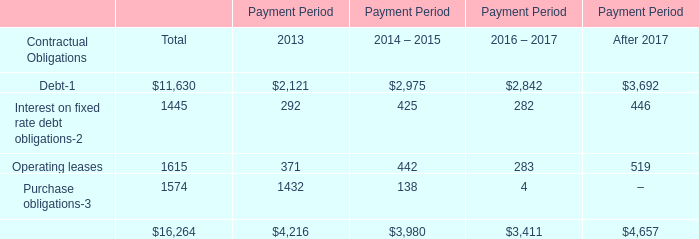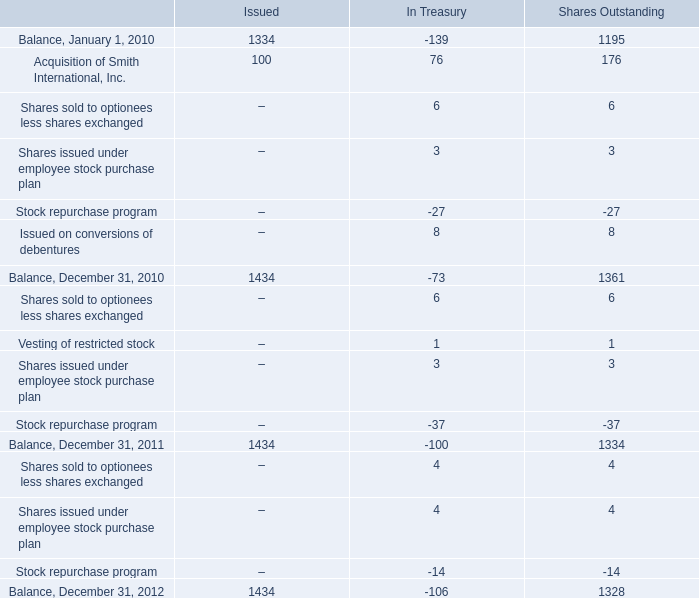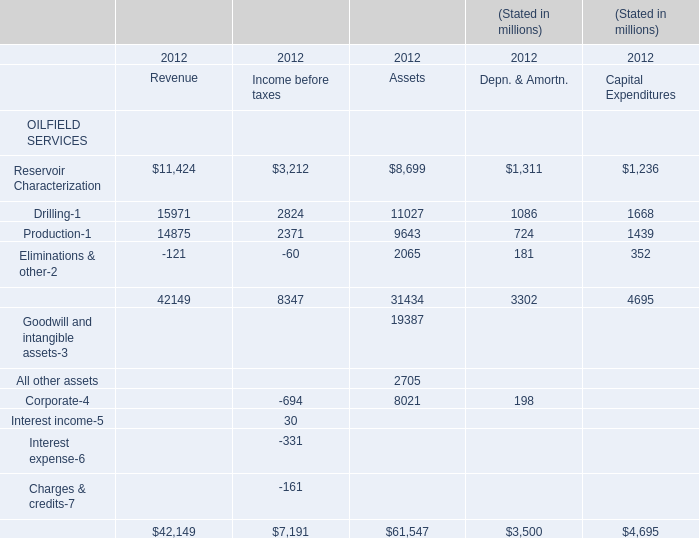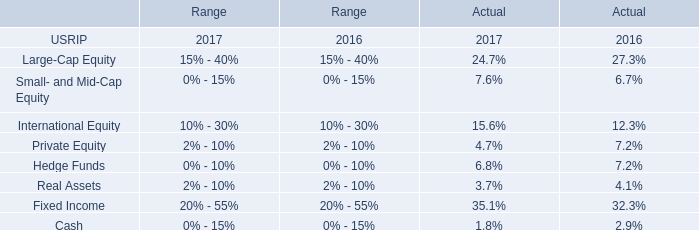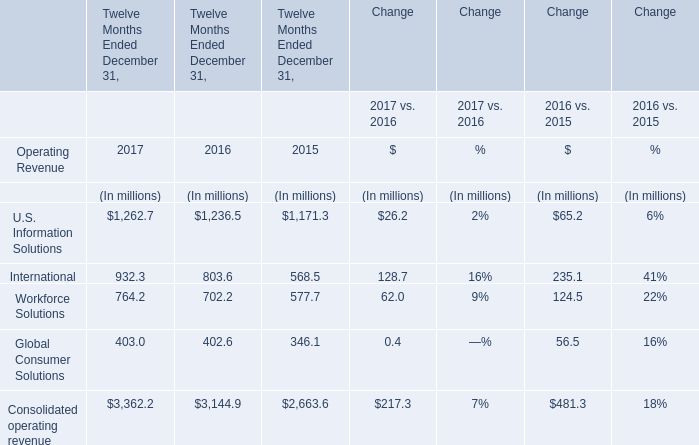How many element exceed the average of Reservoir and Characterization in Revenue Income before taxes in revenue? 
Answer: 4. 